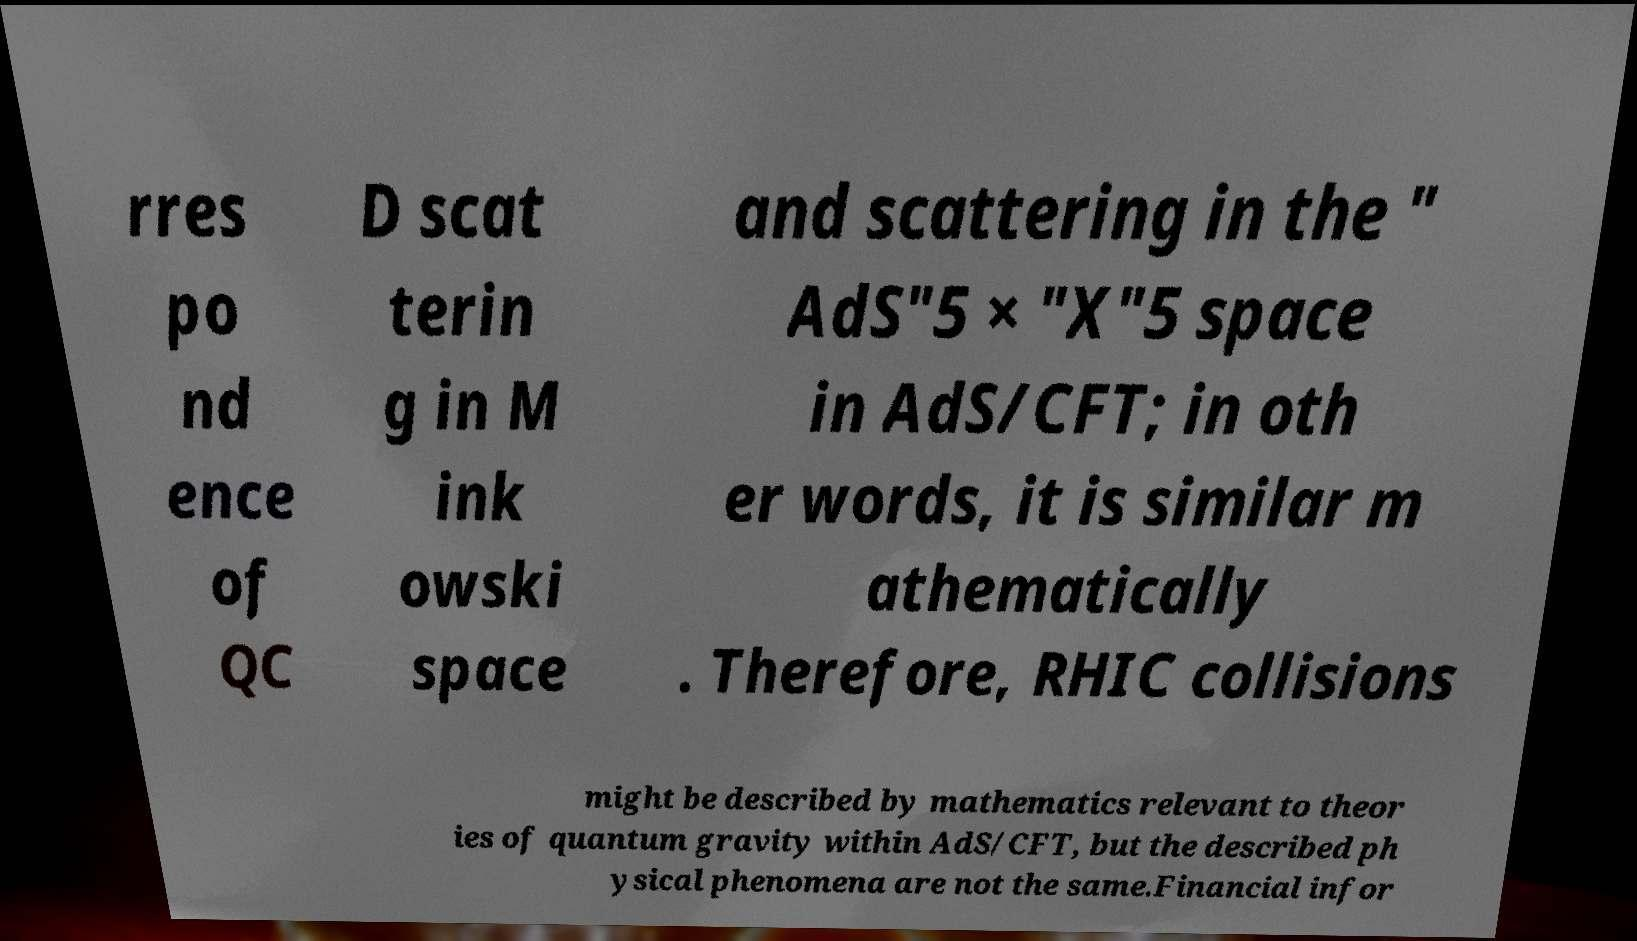I need the written content from this picture converted into text. Can you do that? rres po nd ence of QC D scat terin g in M ink owski space and scattering in the " AdS"5 × "X"5 space in AdS/CFT; in oth er words, it is similar m athematically . Therefore, RHIC collisions might be described by mathematics relevant to theor ies of quantum gravity within AdS/CFT, but the described ph ysical phenomena are not the same.Financial infor 